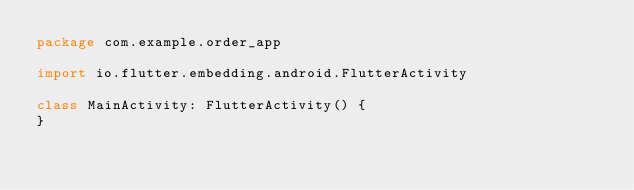Convert code to text. <code><loc_0><loc_0><loc_500><loc_500><_Kotlin_>package com.example.order_app

import io.flutter.embedding.android.FlutterActivity

class MainActivity: FlutterActivity() {
}
</code> 